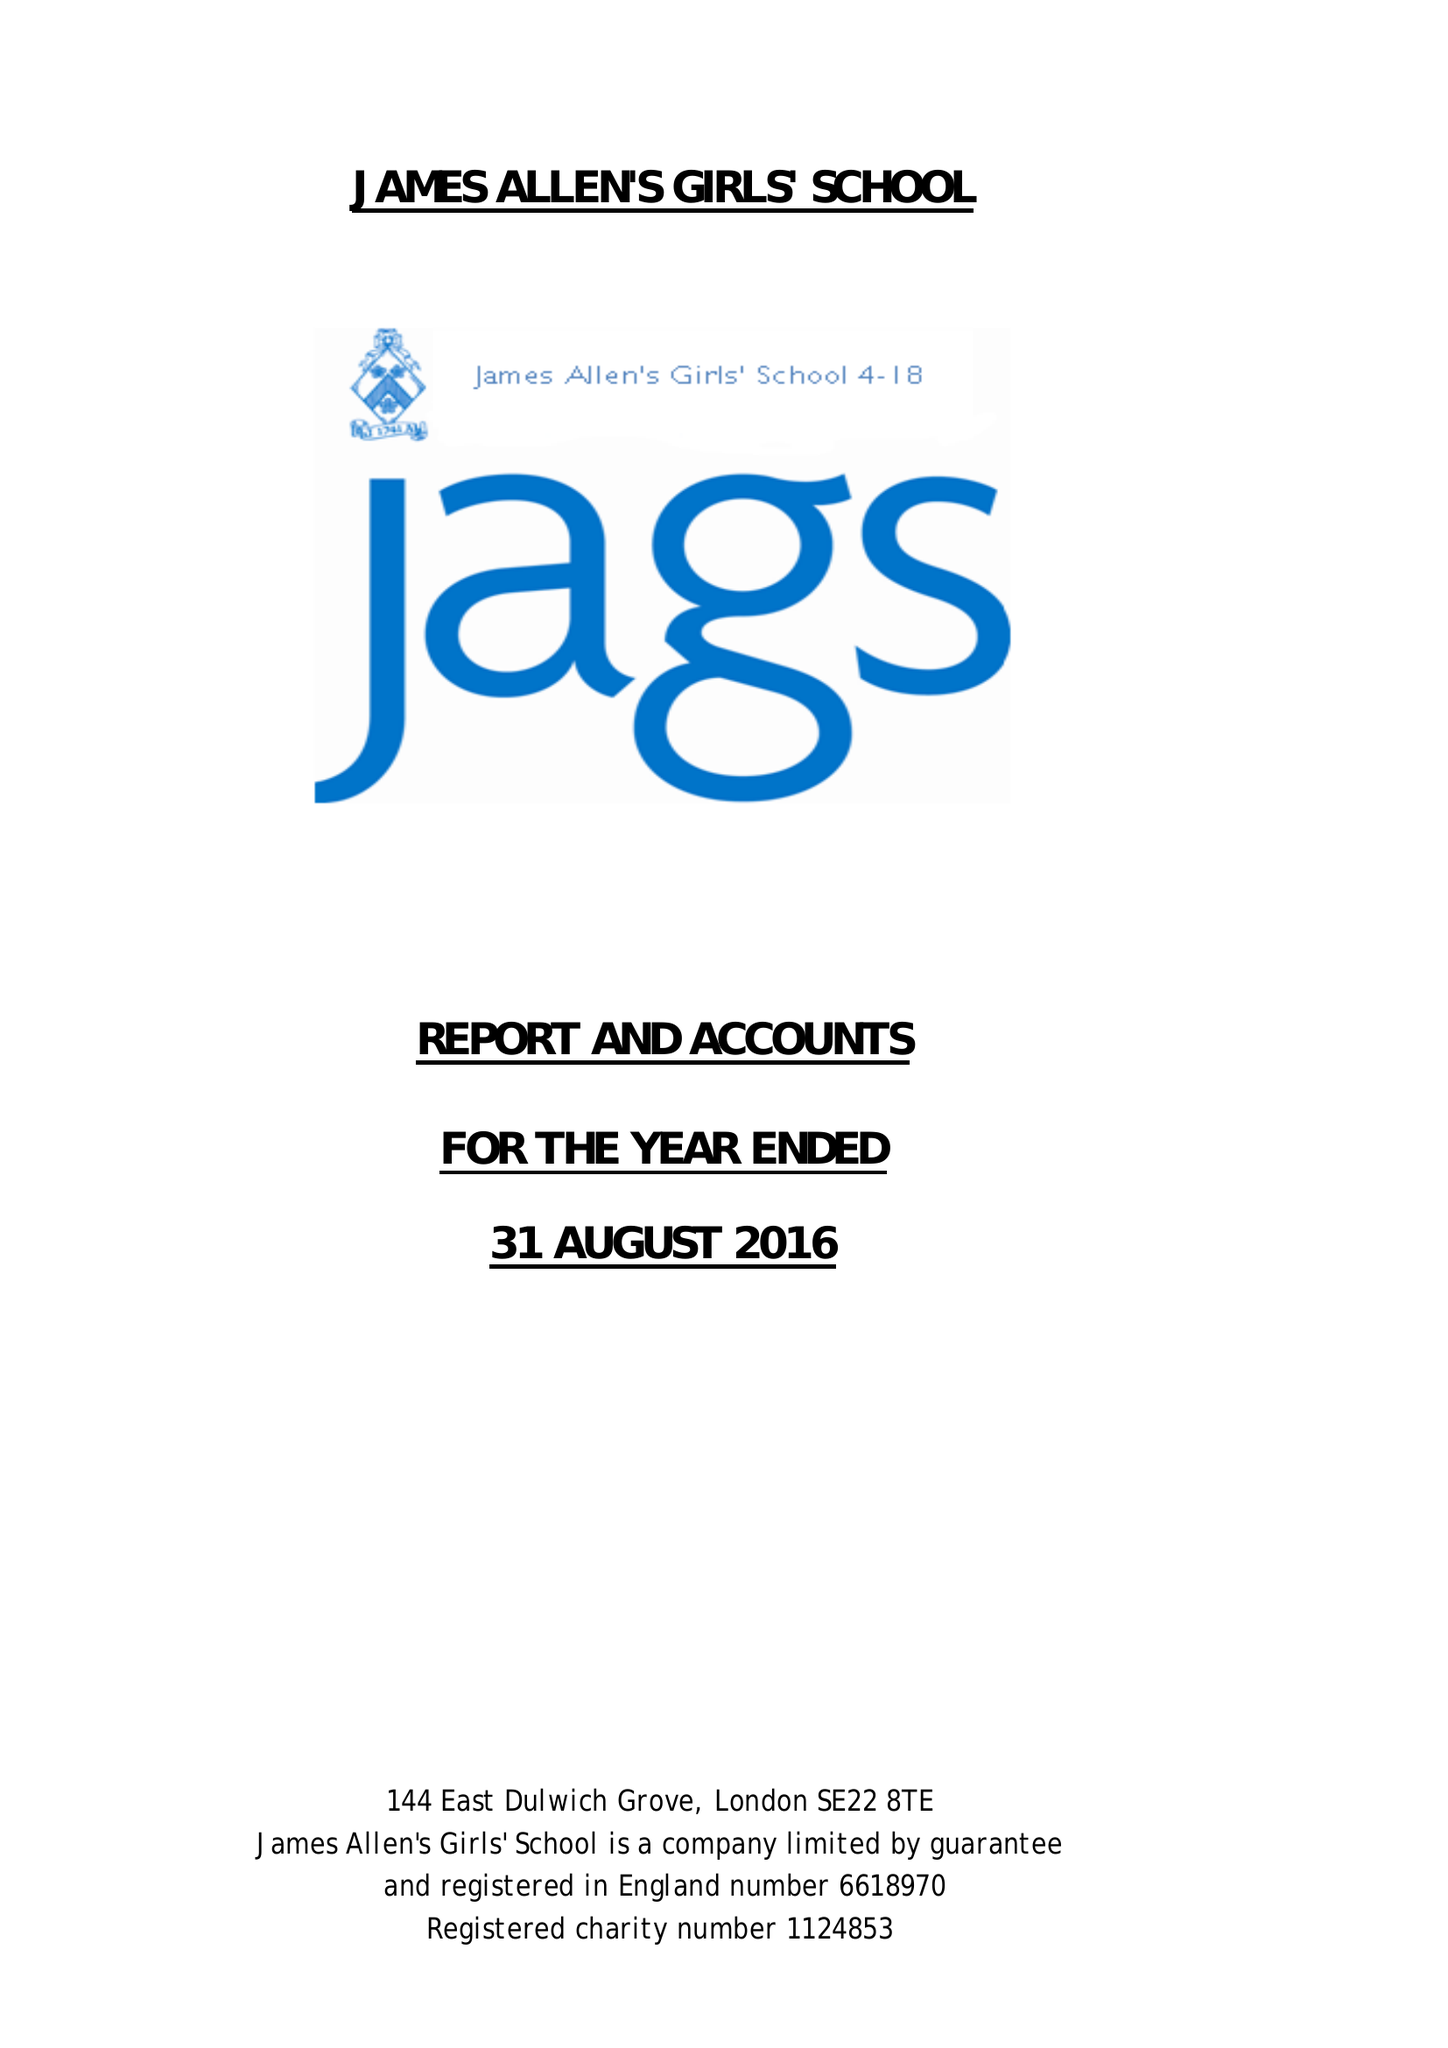What is the value for the address__postcode?
Answer the question using a single word or phrase. SE22 8TE 